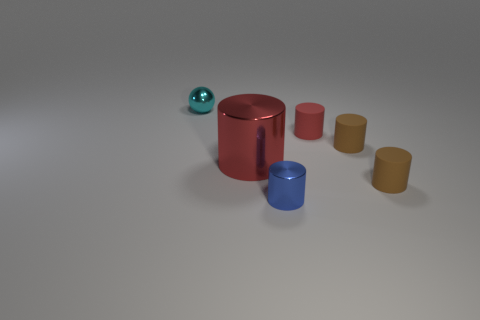Subtract all gray cubes. How many brown cylinders are left? 2 Subtract all big shiny cylinders. How many cylinders are left? 4 Subtract all blue cylinders. How many cylinders are left? 4 Add 1 small blue cylinders. How many objects exist? 7 Subtract all cyan cylinders. Subtract all purple spheres. How many cylinders are left? 5 Subtract all cylinders. How many objects are left? 1 Subtract all big red metallic objects. Subtract all tiny cyan shiny balls. How many objects are left? 4 Add 5 small cyan things. How many small cyan things are left? 6 Add 1 red shiny cylinders. How many red shiny cylinders exist? 2 Subtract 0 green balls. How many objects are left? 6 